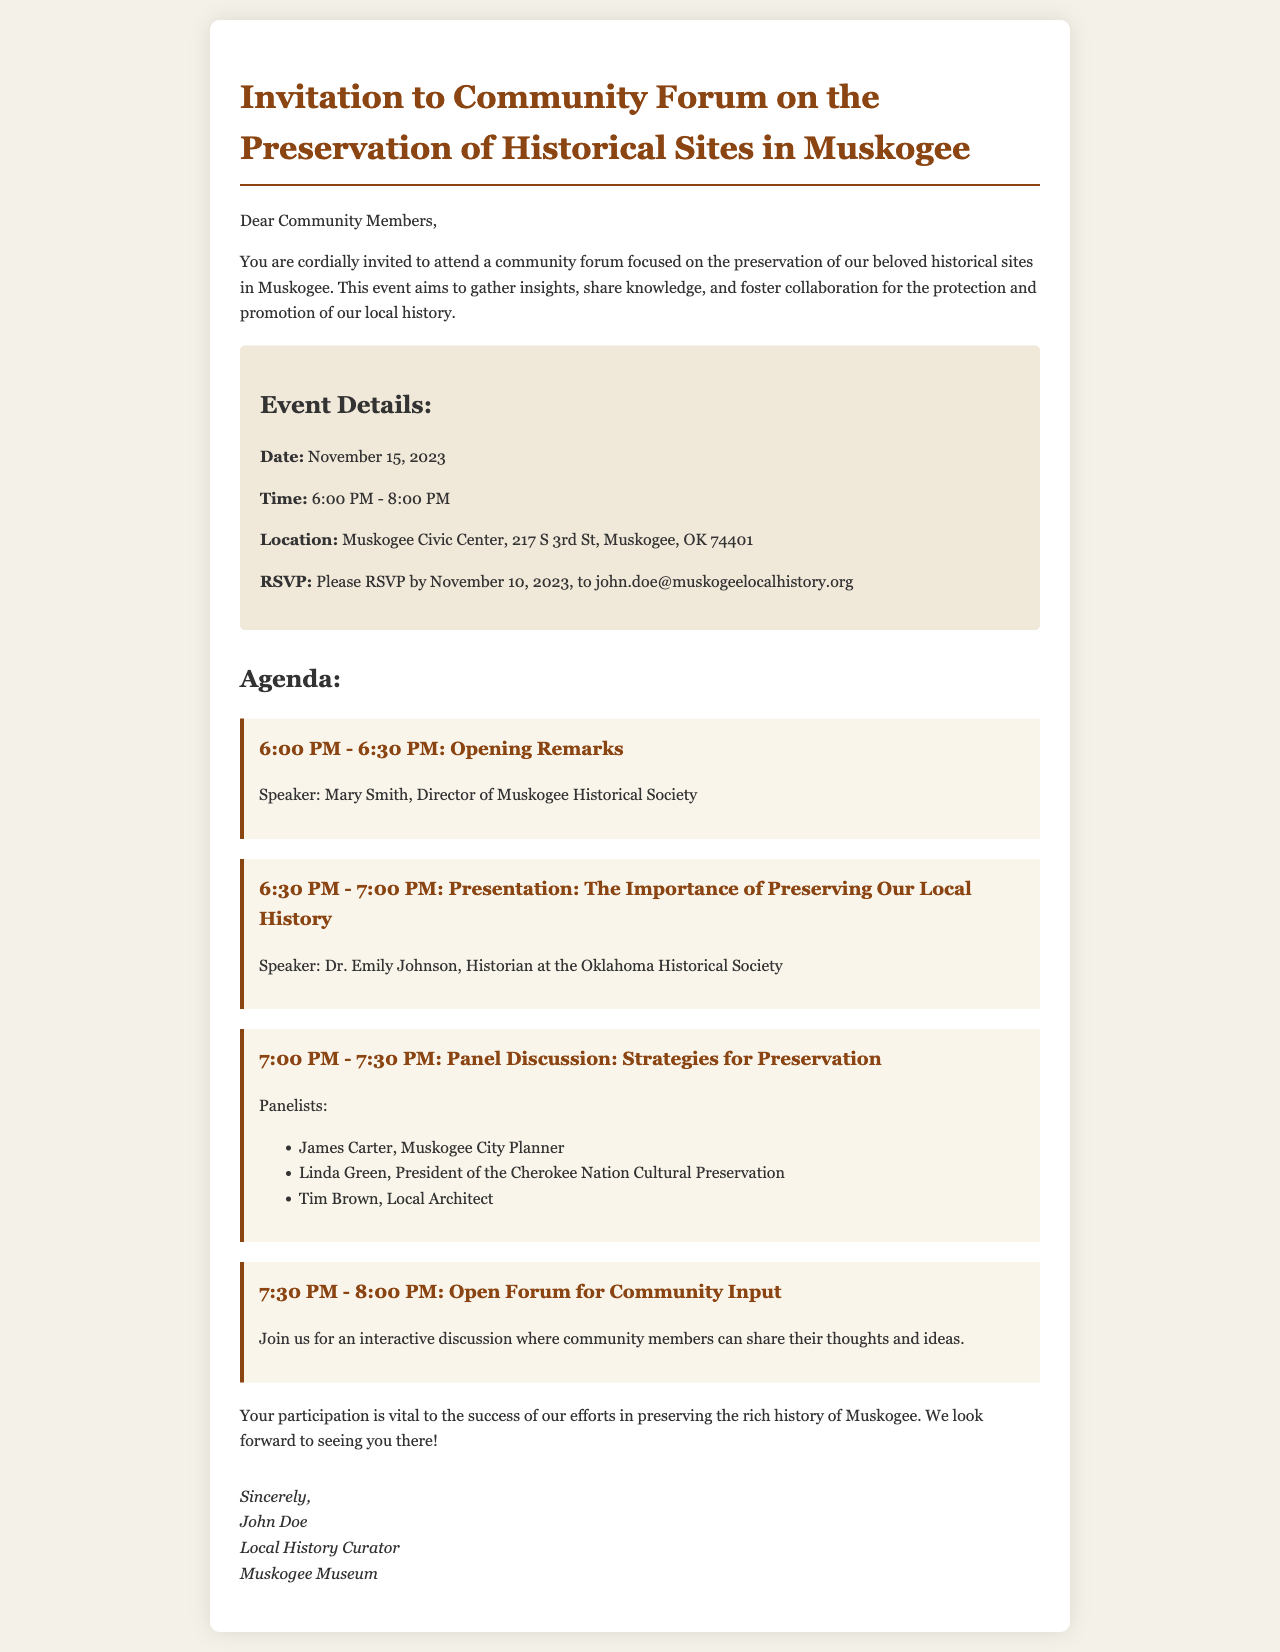What is the date of the community forum? The date of the community forum is explicitly mentioned in the event details section of the document.
Answer: November 15, 2023 What is the time of the community forum? The time of the community forum is provided in the event details, showing when the event starts and ends.
Answer: 6:00 PM - 8:00 PM Who is the speaker for the opening remarks? The speaker for the opening remarks is specified in the agenda section alongside the time of the remarks.
Answer: Mary Smith What is the location of the event? The location where the community forum will take place is clearly listed in the event details.
Answer: Muskogee Civic Center, 217 S 3rd St, Muskogee, OK 74401 When is the RSVP deadline? The RSVP deadline is found in the event details, indicating the last date for attendees to confirm their participation.
Answer: November 10, 2023 Who is the panelist from the Cherokee Nation Cultural Preservation? The document lists the panelists for the discussion, clearly identifying each.
Answer: Linda Green What topic is Dr. Emily Johnson presenting on? Dr. Emily Johnson's presentation topic can be found in the agenda under her scheduled time.
Answer: The Importance of Preserving Our Local History What is the format of the last agenda item? The format of the last agenda item indicates the style of interaction that will occur during that portion of the event.
Answer: Open Forum for Community Input Why is community participation emphasized in the document? The closing remarks stress the importance of community involvement for the success of preservation efforts, highlighting why attendees should participate.
Answer: Vital to the success of our efforts in preserving the rich history of Muskogee 